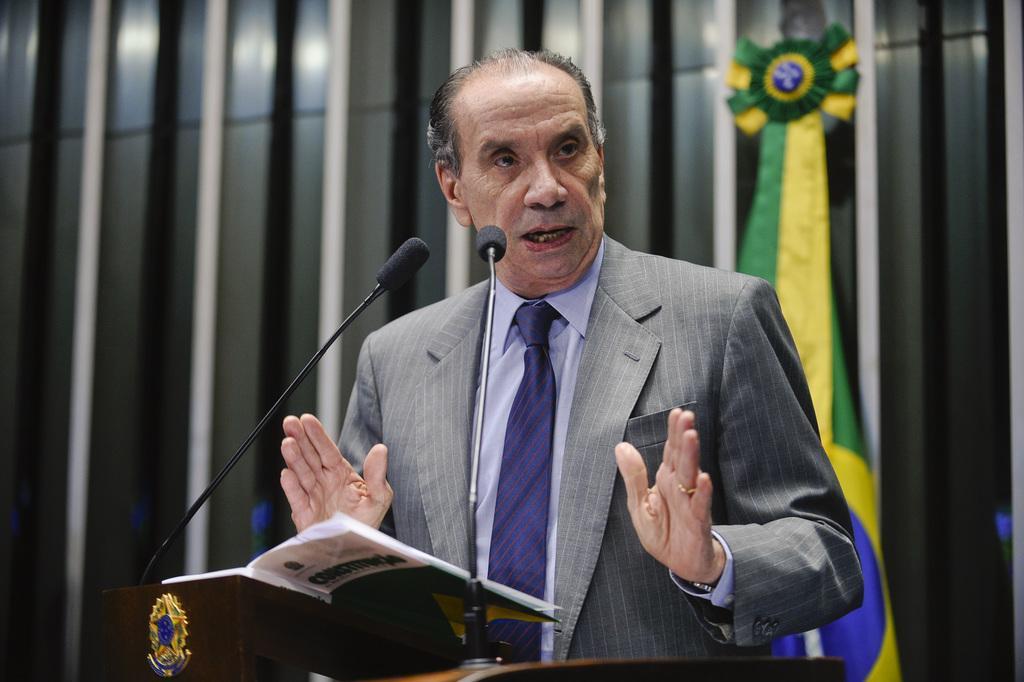Can you describe this image briefly? In the background we can see a flag. We can see man wearing a shirt, tie, blazer, a ring to his finger and a wrist watch. He is talking. Here we can see a book on the table. These are mike's. 